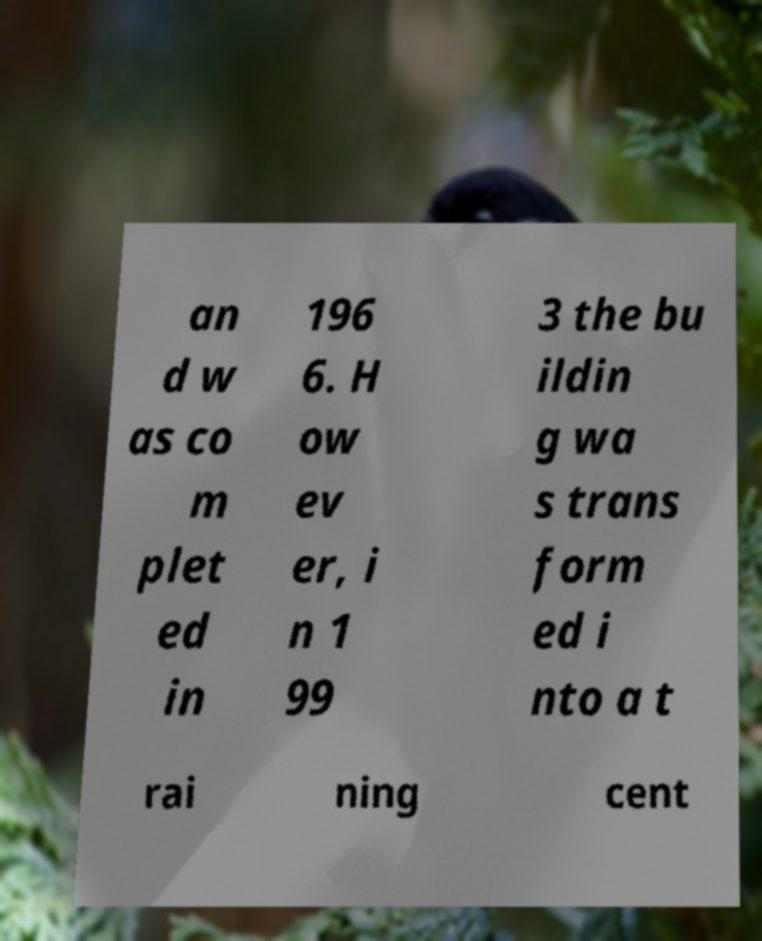I need the written content from this picture converted into text. Can you do that? an d w as co m plet ed in 196 6. H ow ev er, i n 1 99 3 the bu ildin g wa s trans form ed i nto a t rai ning cent 